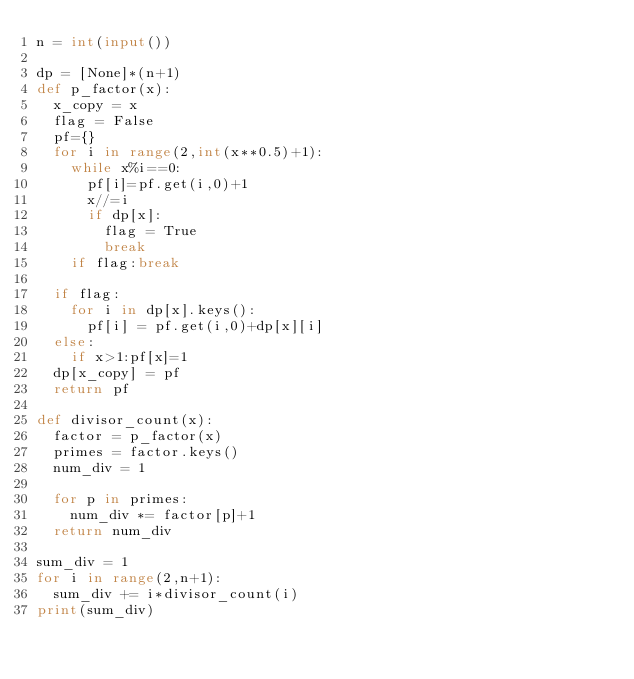Convert code to text. <code><loc_0><loc_0><loc_500><loc_500><_Python_>n = int(input())

dp = [None]*(n+1)
def p_factor(x):
  x_copy = x
  flag = False
  pf={}
  for i in range(2,int(x**0.5)+1):
    while x%i==0:
      pf[i]=pf.get(i,0)+1
      x//=i
      if dp[x]:
        flag = True
        break
    if flag:break        		
   
  if flag:
    for i in dp[x].keys():
      pf[i] = pf.get(i,0)+dp[x][i]
  else:
    if x>1:pf[x]=1
  dp[x_copy] = pf
  return pf

def divisor_count(x):
  factor = p_factor(x)
  primes = factor.keys()
  num_div = 1
  
  for p in primes:
    num_div *= factor[p]+1
  return num_div

sum_div = 1
for i in range(2,n+1):
  sum_div += i*divisor_count(i)
print(sum_div)</code> 